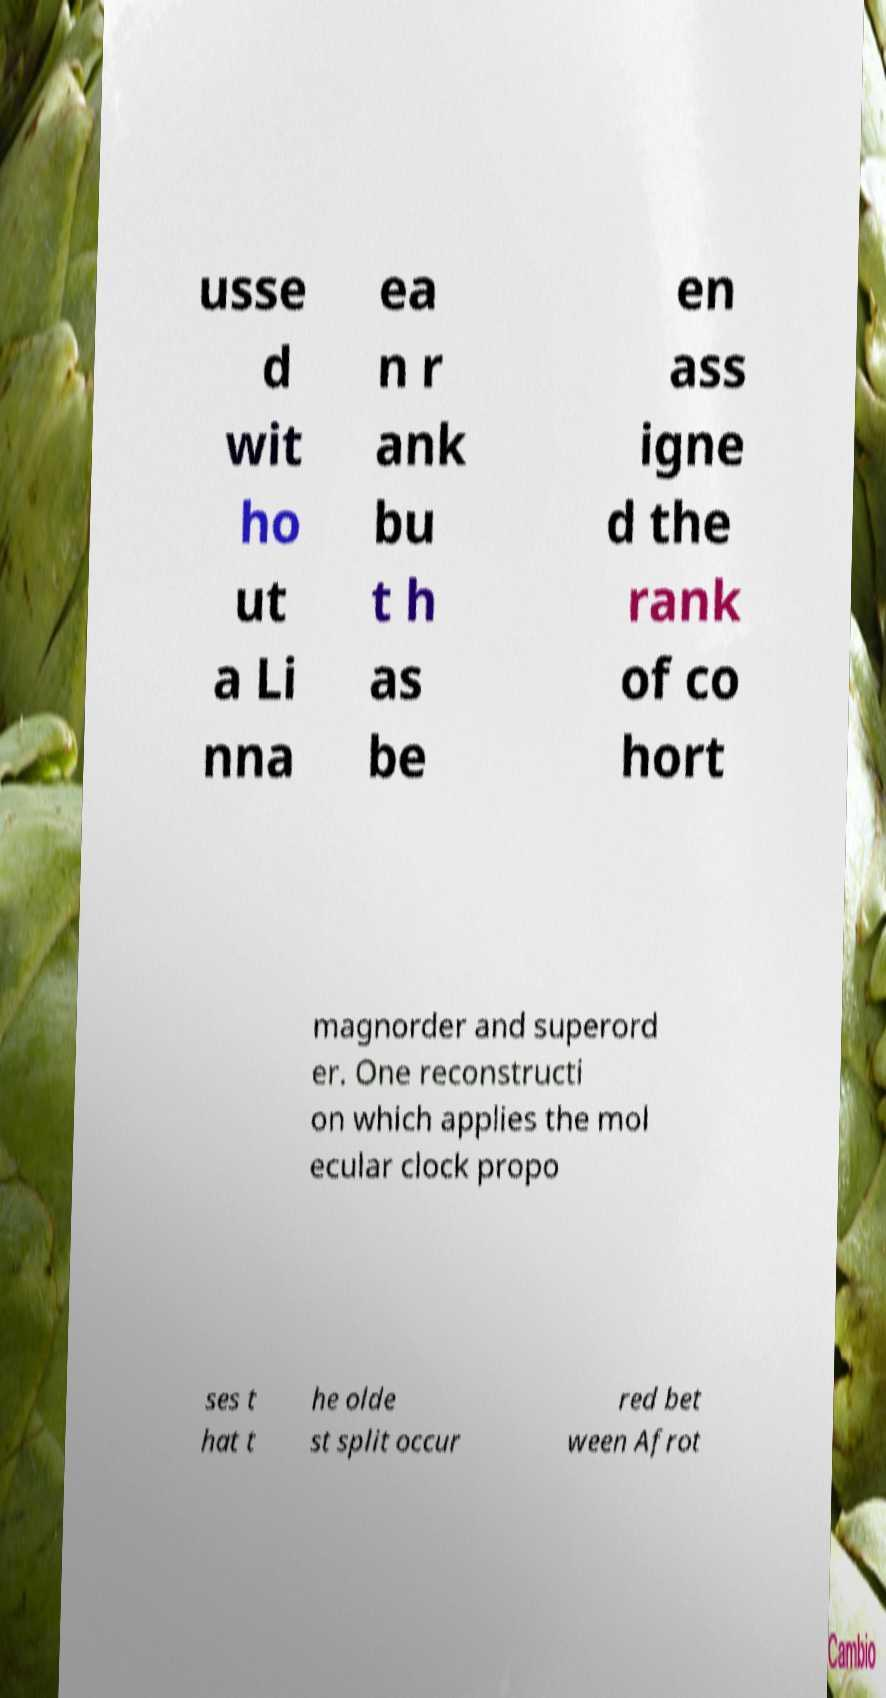Please read and relay the text visible in this image. What does it say? usse d wit ho ut a Li nna ea n r ank bu t h as be en ass igne d the rank of co hort magnorder and superord er. One reconstructi on which applies the mol ecular clock propo ses t hat t he olde st split occur red bet ween Afrot 